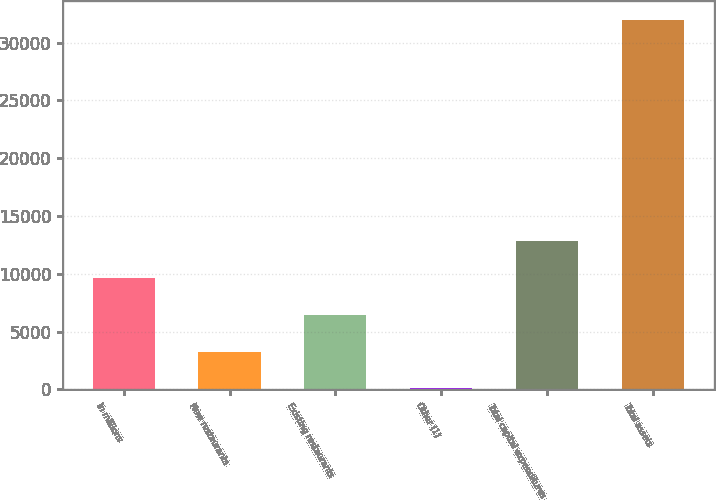Convert chart. <chart><loc_0><loc_0><loc_500><loc_500><bar_chart><fcel>In millions<fcel>New restaurants<fcel>Existing restaurants<fcel>Other (1)<fcel>Total capital expenditures<fcel>Total assets<nl><fcel>9647.1<fcel>3267.7<fcel>6457.4<fcel>78<fcel>12836.8<fcel>31975<nl></chart> 